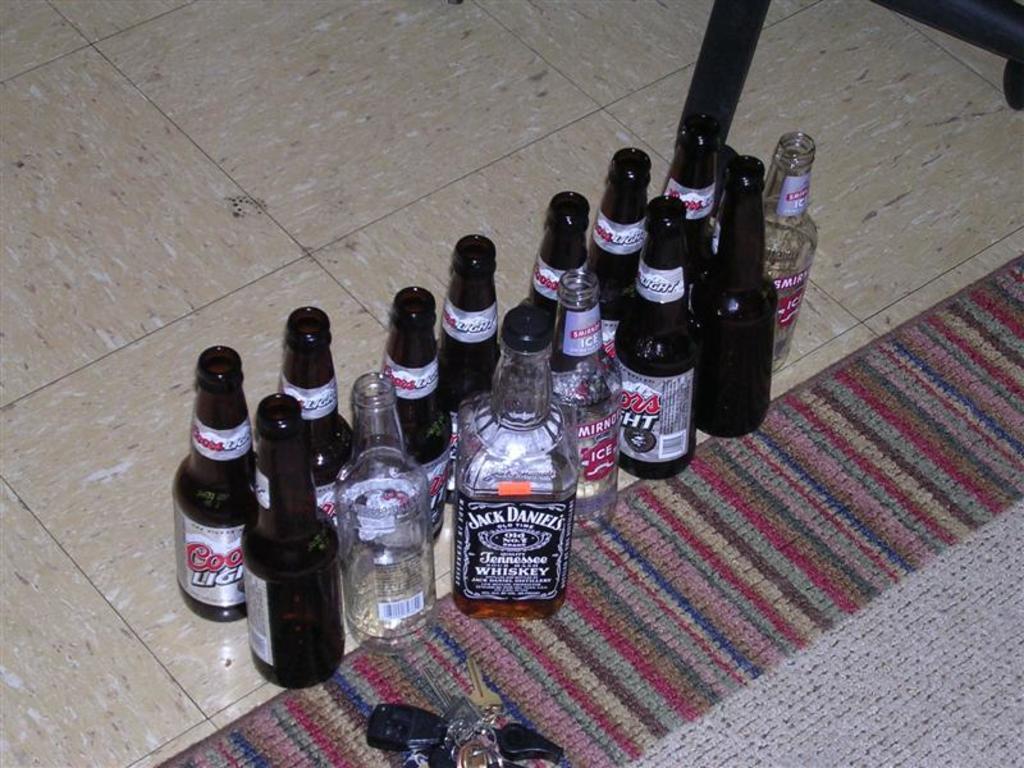What brand of beer is in the brown bottles?
Your answer should be very brief. Coors light. 